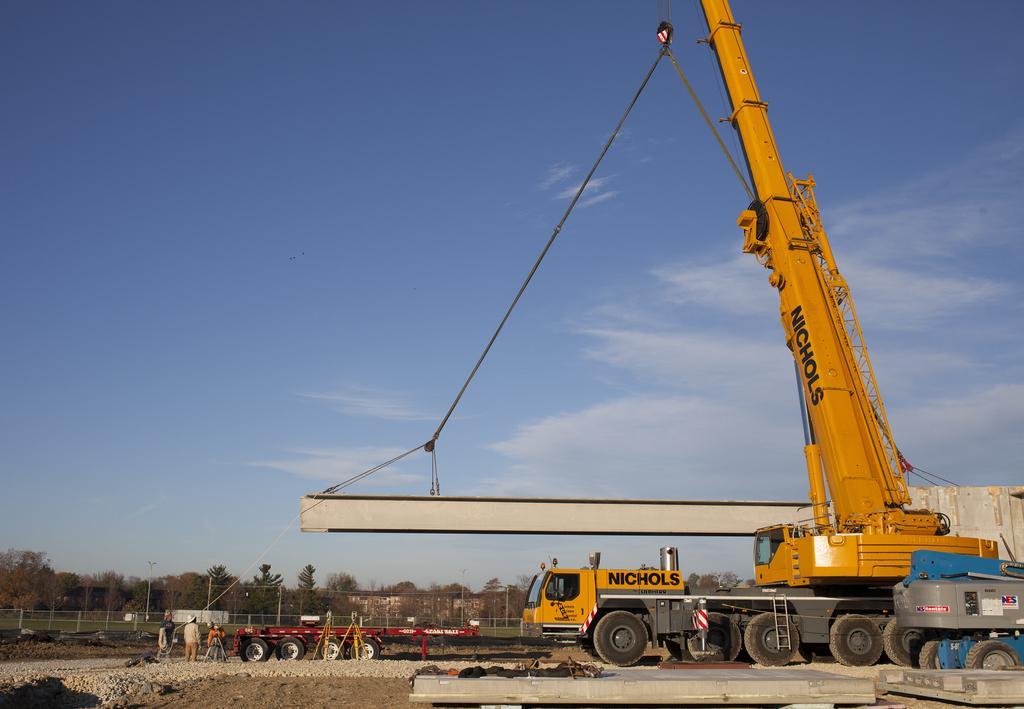Could you give a brief overview of what you see in this image? In this picture we can see a crane on the right side, we can see a vehicle in the middle, in the background there is a fencing and some trees, there are three persons standing in the middle, at the bottom there are some stones, we can see the sky and clouds at the top of the picture. 